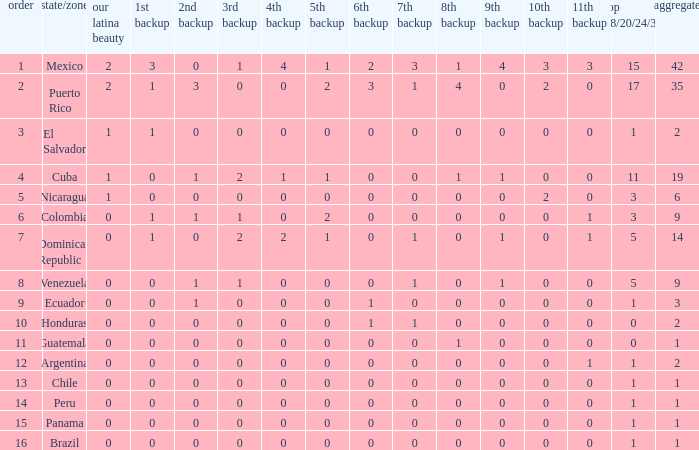What is the 9th runner-up with a top 18/20/24/30 greater than 17 and a 5th runner-up of 2? None. 